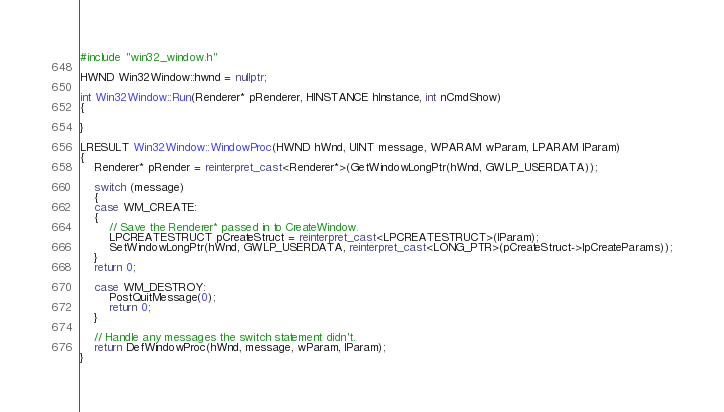Convert code to text. <code><loc_0><loc_0><loc_500><loc_500><_C++_>#include "win32_window.h"

HWND Win32Window::hwnd = nullptr;

int Win32Window::Run(Renderer* pRenderer, HINSTANCE hInstance, int nCmdShow)
{

}

LRESULT Win32Window::WindowProc(HWND hWnd, UINT message, WPARAM wParam, LPARAM lParam)
{
	Renderer* pRender = reinterpret_cast<Renderer*>(GetWindowLongPtr(hWnd, GWLP_USERDATA));

	switch (message)
	{
	case WM_CREATE:
	{
		// Save the Renderer* passed in to CreateWindow.
		LPCREATESTRUCT pCreateStruct = reinterpret_cast<LPCREATESTRUCT>(lParam);
		SetWindowLongPtr(hWnd, GWLP_USERDATA, reinterpret_cast<LONG_PTR>(pCreateStruct->lpCreateParams));
	}
	return 0;

	case WM_DESTROY:
		PostQuitMessage(0);
		return 0;
	}

	// Handle any messages the switch statement didn't.
	return DefWindowProc(hWnd, message, wParam, lParam);
}
</code> 